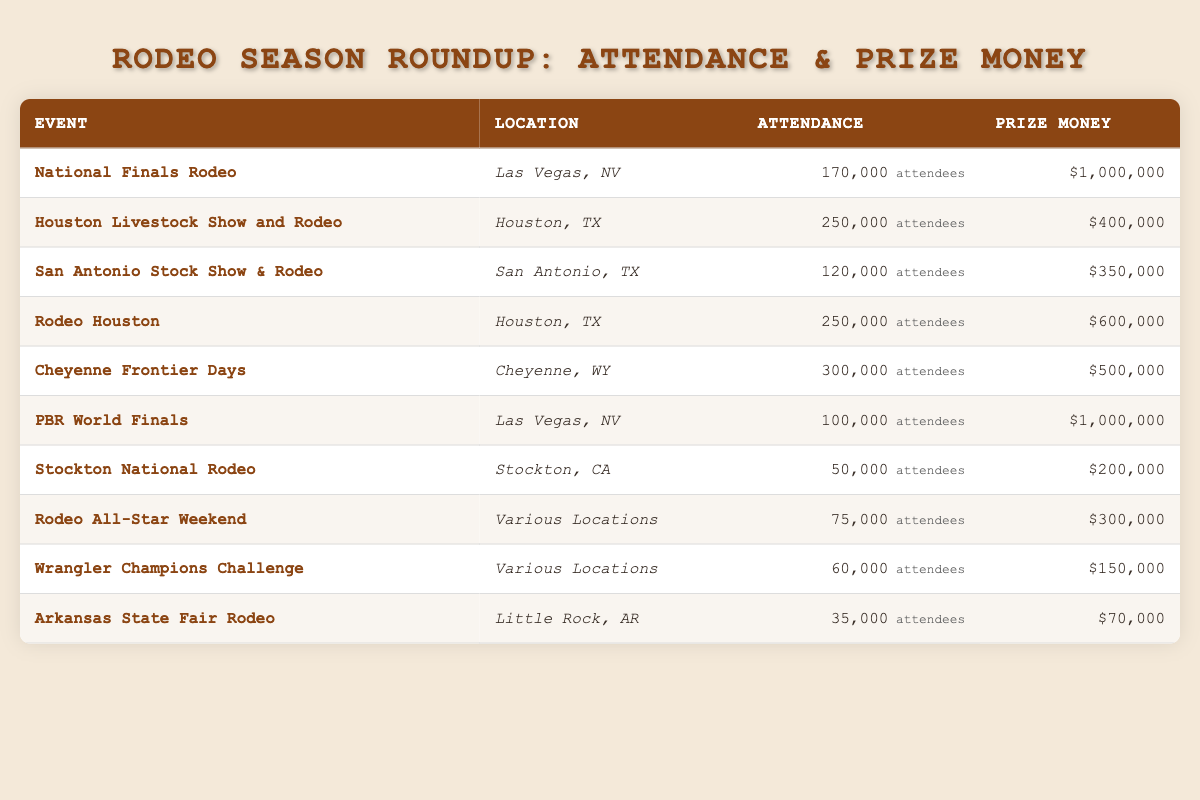What is the attendance at the National Finals Rodeo? The data shows that the attendance for the National Finals Rodeo is specifically listed as 170,000.
Answer: 170,000 Which event has the highest prize money? The National Finals Rodeo and the PBR World Finals both have the highest prize money of 1,000,000.
Answer: National Finals Rodeo and PBR World Finals What is the prize money for the Cheyenne Frontier Days event? The table lists the prize money for the Cheyenne Frontier Days event as 500,000.
Answer: 500,000 What is the total attendance of the Rodeo Houston and the Houston Livestock Show and Rodeo? Adding the attendance for Rodeo Houston (250,000) and Houston Livestock Show and Rodeo (250,000) gives a total of 500,000.
Answer: 500,000 Is the attendance at the Arkansas State Fair Rodeo greater than 40,000? The attendance at the Arkansas State Fair Rodeo is 35,000, which is not greater than 40,000.
Answer: No What is the average prize money across all events listed? The total prize money is 1,000,000 + 400,000 + 350,000 + 600,000 + 500,000 + 1,000,000 + 200,000 + 300,000 + 150,000 + 70,000 = 4,520,000 and there are 10 events, so the average prize money is 4,520,000 / 10 = 452,000.
Answer: 452,000 Which event has the lowest attendance and what is that attendance? The Stockton National Rodeo has the lowest attendance of 50,000 among all events listed in the table.
Answer: 50,000 Are there any events located in Las Vegas, NV? Yes, both the National Finals Rodeo and the PBR World Finals are held in Las Vegas, NV.
Answer: Yes How much higher is the prize money for the Rodeo Houston compared to the prize money for the Arkansas State Fair Rodeo? Rodeo Houston has a prize money of 600,000 and the Arkansas State Fair Rodeo has a prize money of 70,000. The difference is 600,000 - 70,000 = 530,000.
Answer: 530,000 